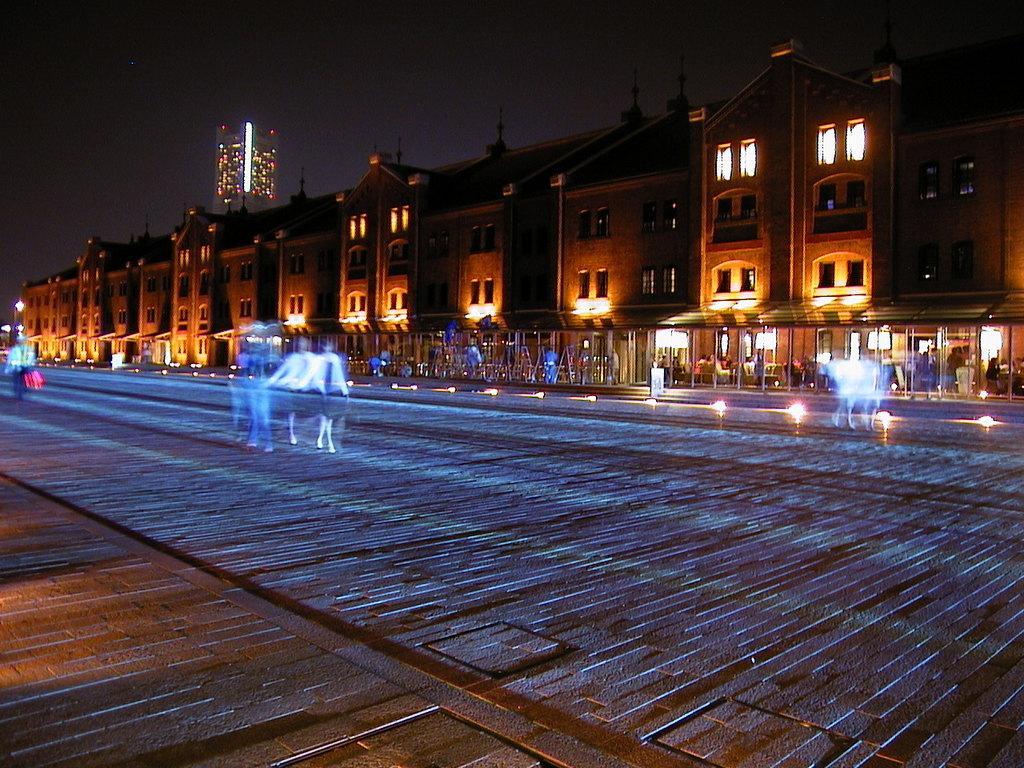Describe this image in one or two sentences. At the bottom of the picture, we see the road. In the middle of the picture, we see two people are walking on the road, but it is blurred. In the background, we see buildings and lights. We see people sitting on the chairs. This picture is clicked in the dark. 